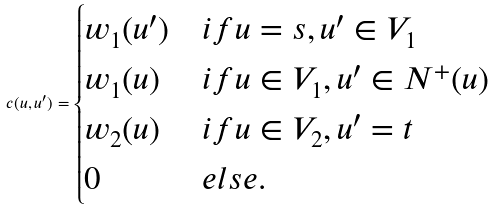<formula> <loc_0><loc_0><loc_500><loc_500>c ( u , u ^ { \prime } ) = \begin{cases} w _ { 1 } ( u ^ { \prime } ) & i f u = s , u ^ { \prime } \in V _ { 1 } \\ w _ { 1 } ( u ) & i f u \in V _ { 1 } , u ^ { \prime } \in N ^ { + } ( u ) \\ w _ { 2 } ( u ) & i f u \in V _ { 2 } , u ^ { \prime } = t \\ 0 & e l s e . \end{cases}</formula> 